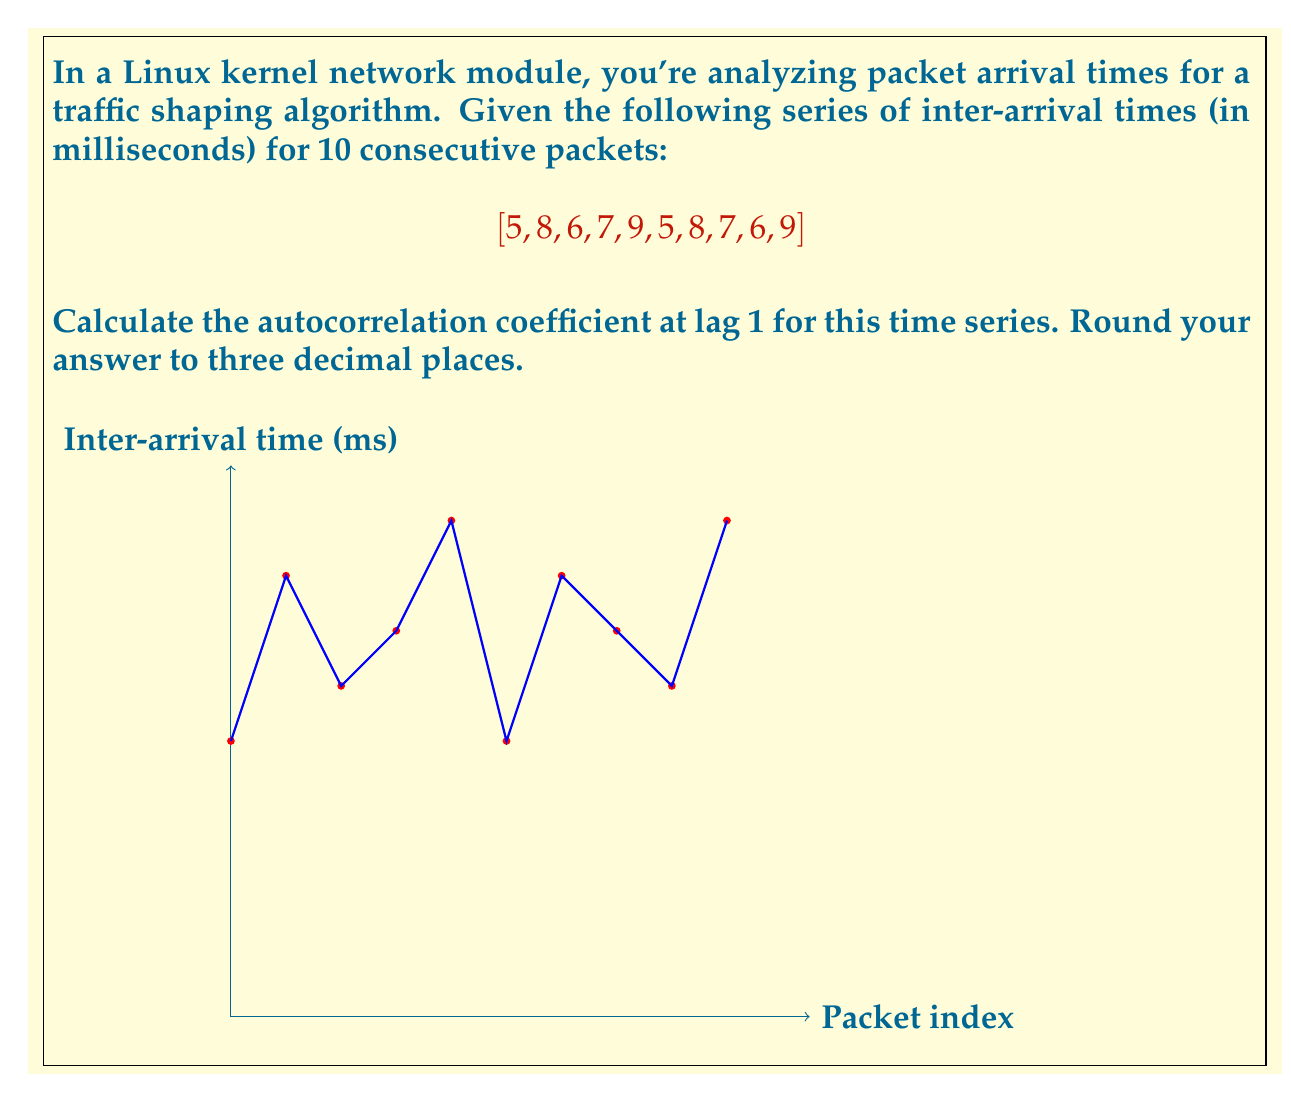Solve this math problem. To calculate the autocorrelation coefficient at lag 1, we'll follow these steps:

1) First, calculate the mean ($\mu$) of the series:
   $$\mu = \frac{5 + 8 + 6 + 7 + 9 + 5 + 8 + 7 + 6 + 9}{10} = 7$$

2) Calculate the variance ($\sigma^2$):
   $$\sigma^2 = \frac{1}{N}\sum_{i=1}^N (x_i - \mu)^2$$
   $$= \frac{1}{10}[(5-7)^2 + (8-7)^2 + (6-7)^2 + ... + (9-7)^2]$$
   $$= \frac{1}{10}[4 + 1 + 1 + 0 + 4 + 4 + 1 + 0 + 1 + 4] = 2$$

3) For lag 1 autocorrelation, we need to calculate:
   $$r_1 = \frac{\sum_{i=1}^{N-1} (x_i - \mu)(x_{i+1} - \mu)}{\sum_{i=1}^N (x_i - \mu)^2}$$

4) Calculate the numerator:
   $$(5-7)(8-7) + (8-7)(6-7) + (6-7)(7-7) + ... + (6-7)(9-7)$$
   $$= (-2)(1) + (1)(-1) + (-1)(0) + (0)(2) + (2)(-2) + (-2)(1) + (1)(-1) + (0)(-1) + (-1)(2)$$
   $$= -2 - 1 + 0 + 0 - 4 - 2 - 1 + 0 - 2 = -12$$

5) The denominator is the sum of squared deviations, which is $N\sigma^2 = 10 * 2 = 20$

6) Therefore, the autocorrelation coefficient at lag 1 is:
   $$r_1 = \frac{-12}{20} = -0.6$$

Rounded to three decimal places, the result is -0.600.
Answer: $-0.600$ 